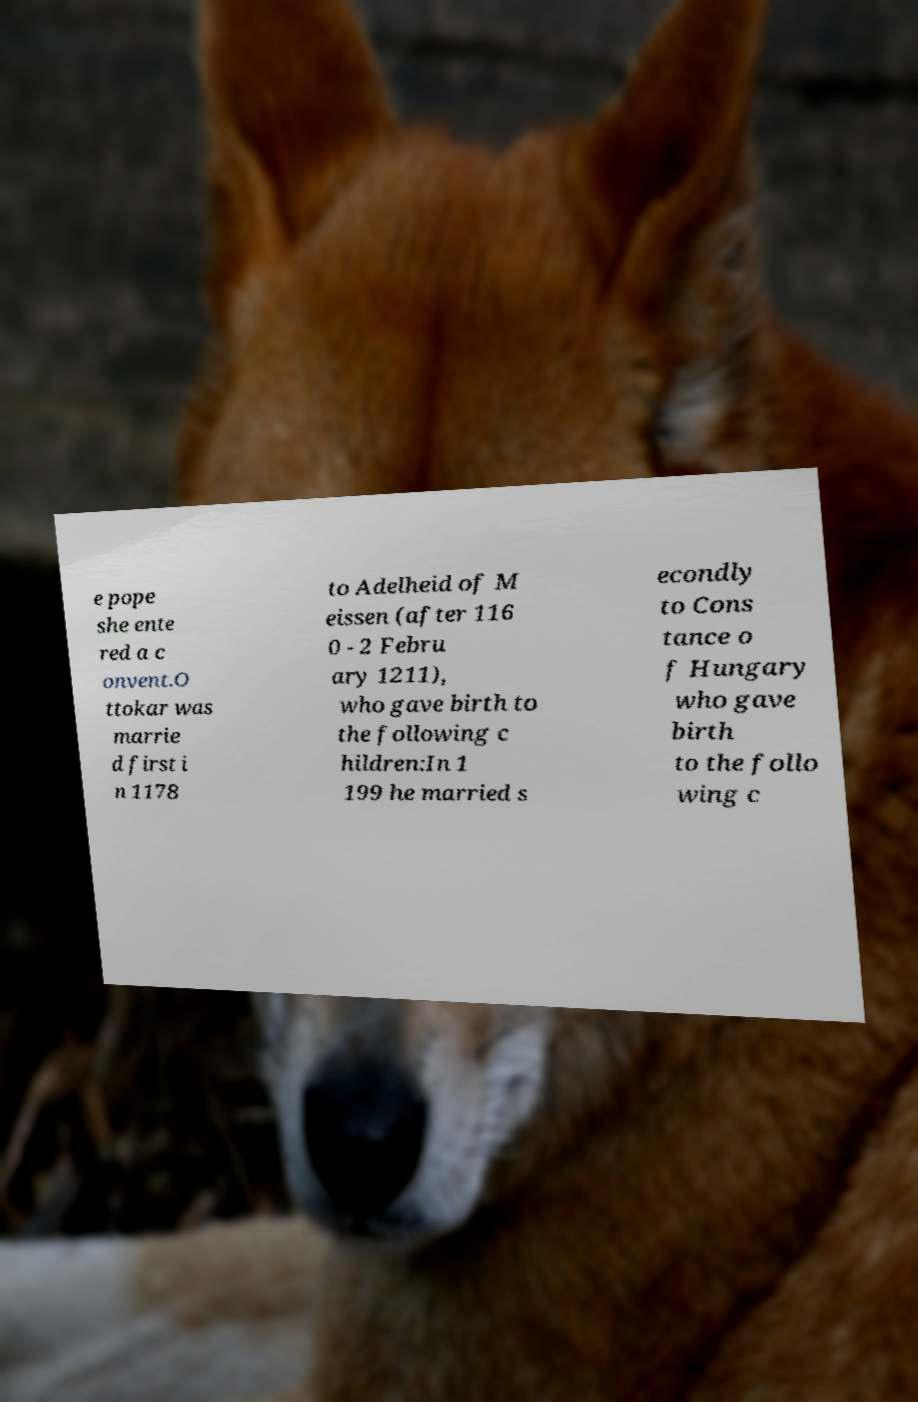Could you assist in decoding the text presented in this image and type it out clearly? e pope she ente red a c onvent.O ttokar was marrie d first i n 1178 to Adelheid of M eissen (after 116 0 - 2 Febru ary 1211), who gave birth to the following c hildren:In 1 199 he married s econdly to Cons tance o f Hungary who gave birth to the follo wing c 